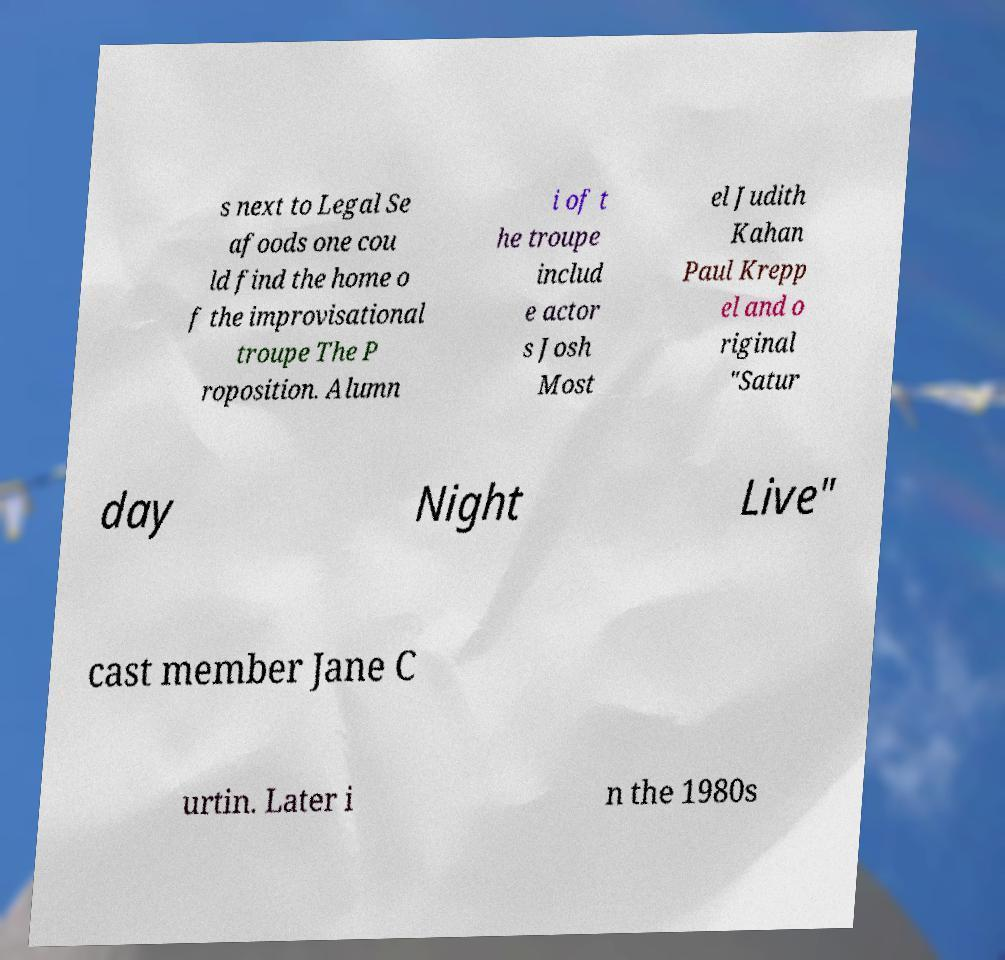What messages or text are displayed in this image? I need them in a readable, typed format. s next to Legal Se afoods one cou ld find the home o f the improvisational troupe The P roposition. Alumn i of t he troupe includ e actor s Josh Most el Judith Kahan Paul Krepp el and o riginal "Satur day Night Live" cast member Jane C urtin. Later i n the 1980s 